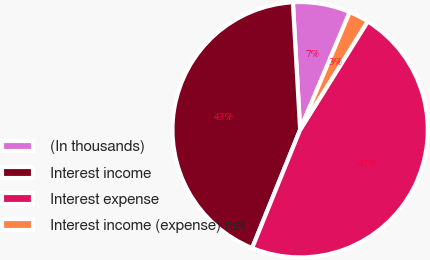Convert chart. <chart><loc_0><loc_0><loc_500><loc_500><pie_chart><fcel>(In thousands)<fcel>Interest income<fcel>Interest expense<fcel>Interest income (expense) net<nl><fcel>7.26%<fcel>42.96%<fcel>47.26%<fcel>2.52%<nl></chart> 